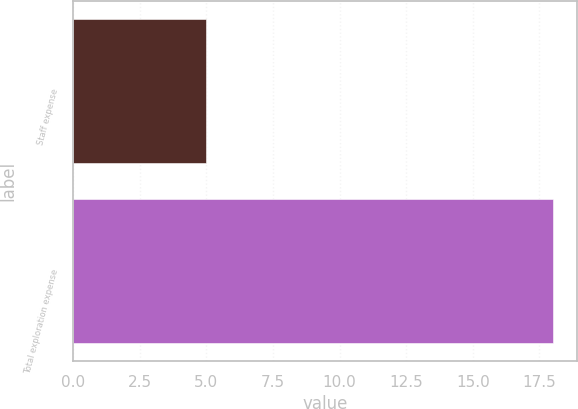Convert chart to OTSL. <chart><loc_0><loc_0><loc_500><loc_500><bar_chart><fcel>Staff expense<fcel>Total exploration expense<nl><fcel>5<fcel>18<nl></chart> 